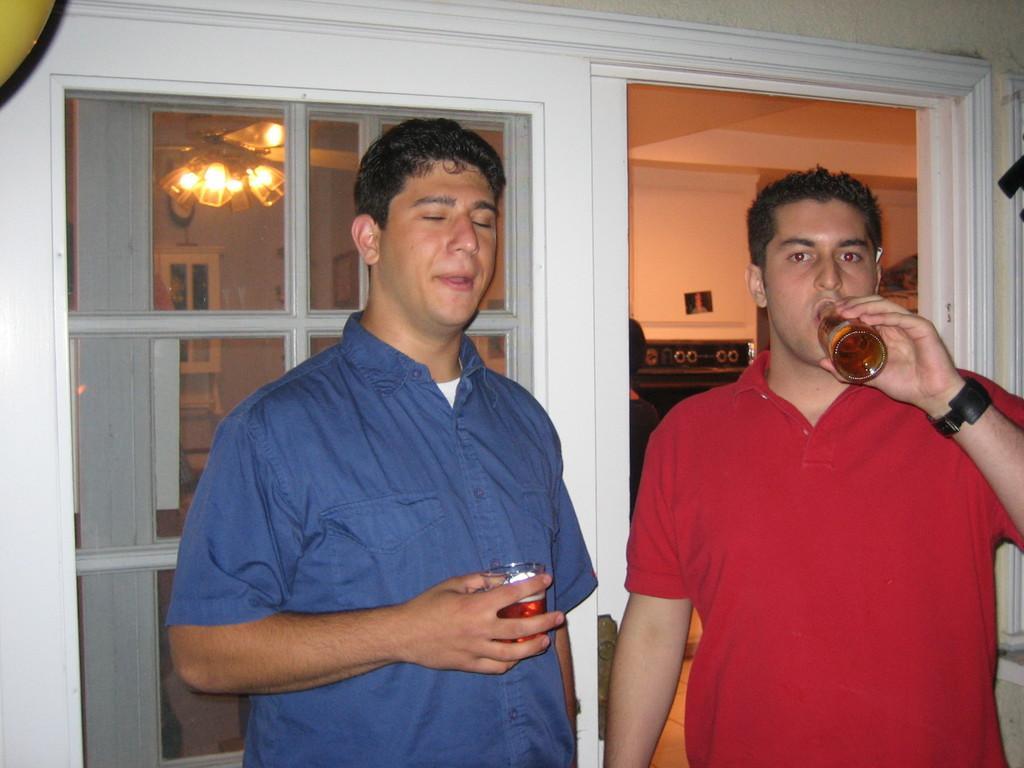Please provide a concise description of this image. In this picture there are two men drinking the wine bottle, standing in front and looking to the camera. Behind we can see the white window glass. In the background there is a room, wall and hanging light. 